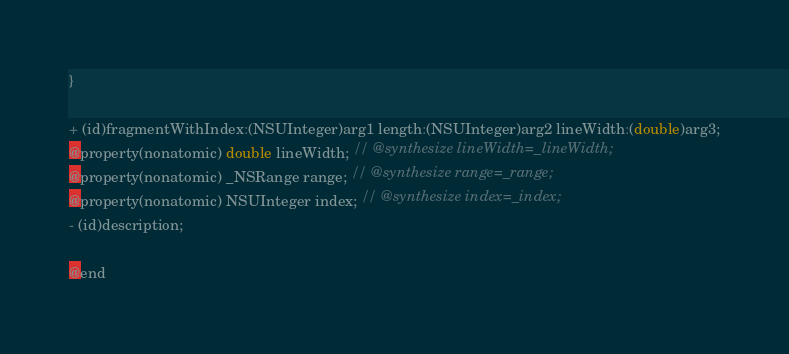<code> <loc_0><loc_0><loc_500><loc_500><_C_>}

+ (id)fragmentWithIndex:(NSUInteger)arg1 length:(NSUInteger)arg2 lineWidth:(double)arg3;
@property(nonatomic) double lineWidth; // @synthesize lineWidth=_lineWidth;
@property(nonatomic) _NSRange range; // @synthesize range=_range;
@property(nonatomic) NSUInteger index; // @synthesize index=_index;
- (id)description;

@end

</code> 